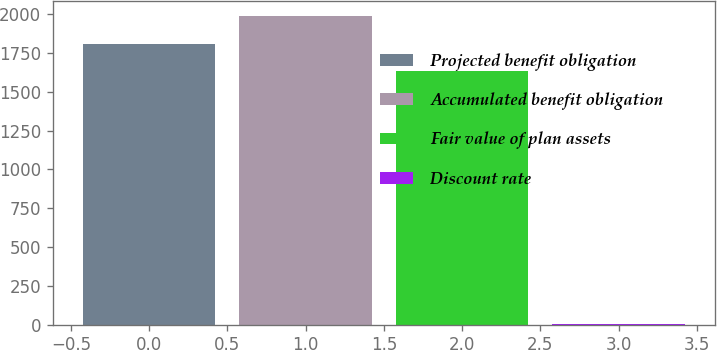Convert chart. <chart><loc_0><loc_0><loc_500><loc_500><bar_chart><fcel>Projected benefit obligation<fcel>Accumulated benefit obligation<fcel>Fair value of plan assets<fcel>Discount rate<nl><fcel>1810.25<fcel>1984.5<fcel>1636<fcel>5.5<nl></chart> 